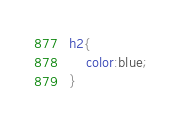<code> <loc_0><loc_0><loc_500><loc_500><_CSS_>h2{
    color:blue;
}
</code> 